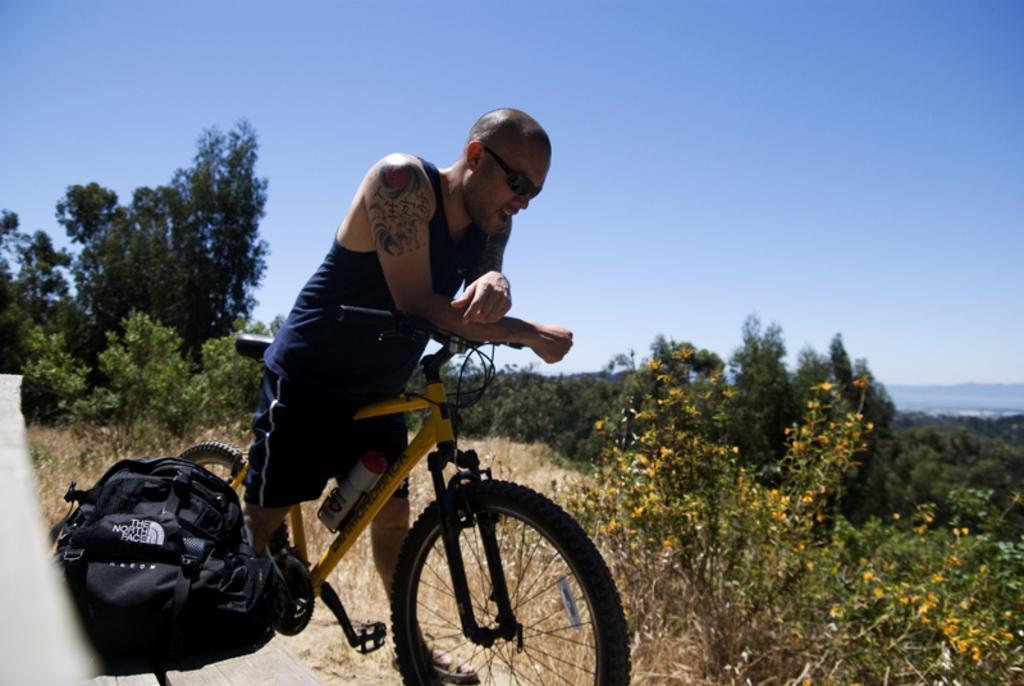In one or two sentences, can you explain what this image depicts? In this image I can see a person is on the bicycle. To the right of him there is a bag. In the background there are trees and a sky. 